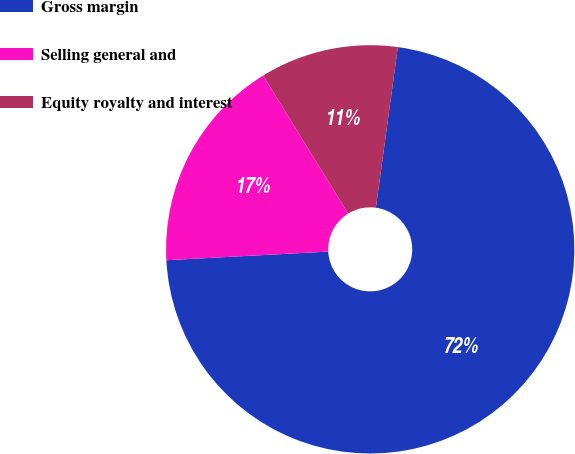Convert chart to OTSL. <chart><loc_0><loc_0><loc_500><loc_500><pie_chart><fcel>Gross margin<fcel>Selling general and<fcel>Equity royalty and interest<nl><fcel>71.99%<fcel>17.06%<fcel>10.95%<nl></chart> 